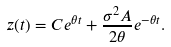<formula> <loc_0><loc_0><loc_500><loc_500>z ( t ) = C e ^ { \theta t } + \frac { \sigma ^ { 2 } A } { 2 \theta } e ^ { - \theta t } .</formula> 